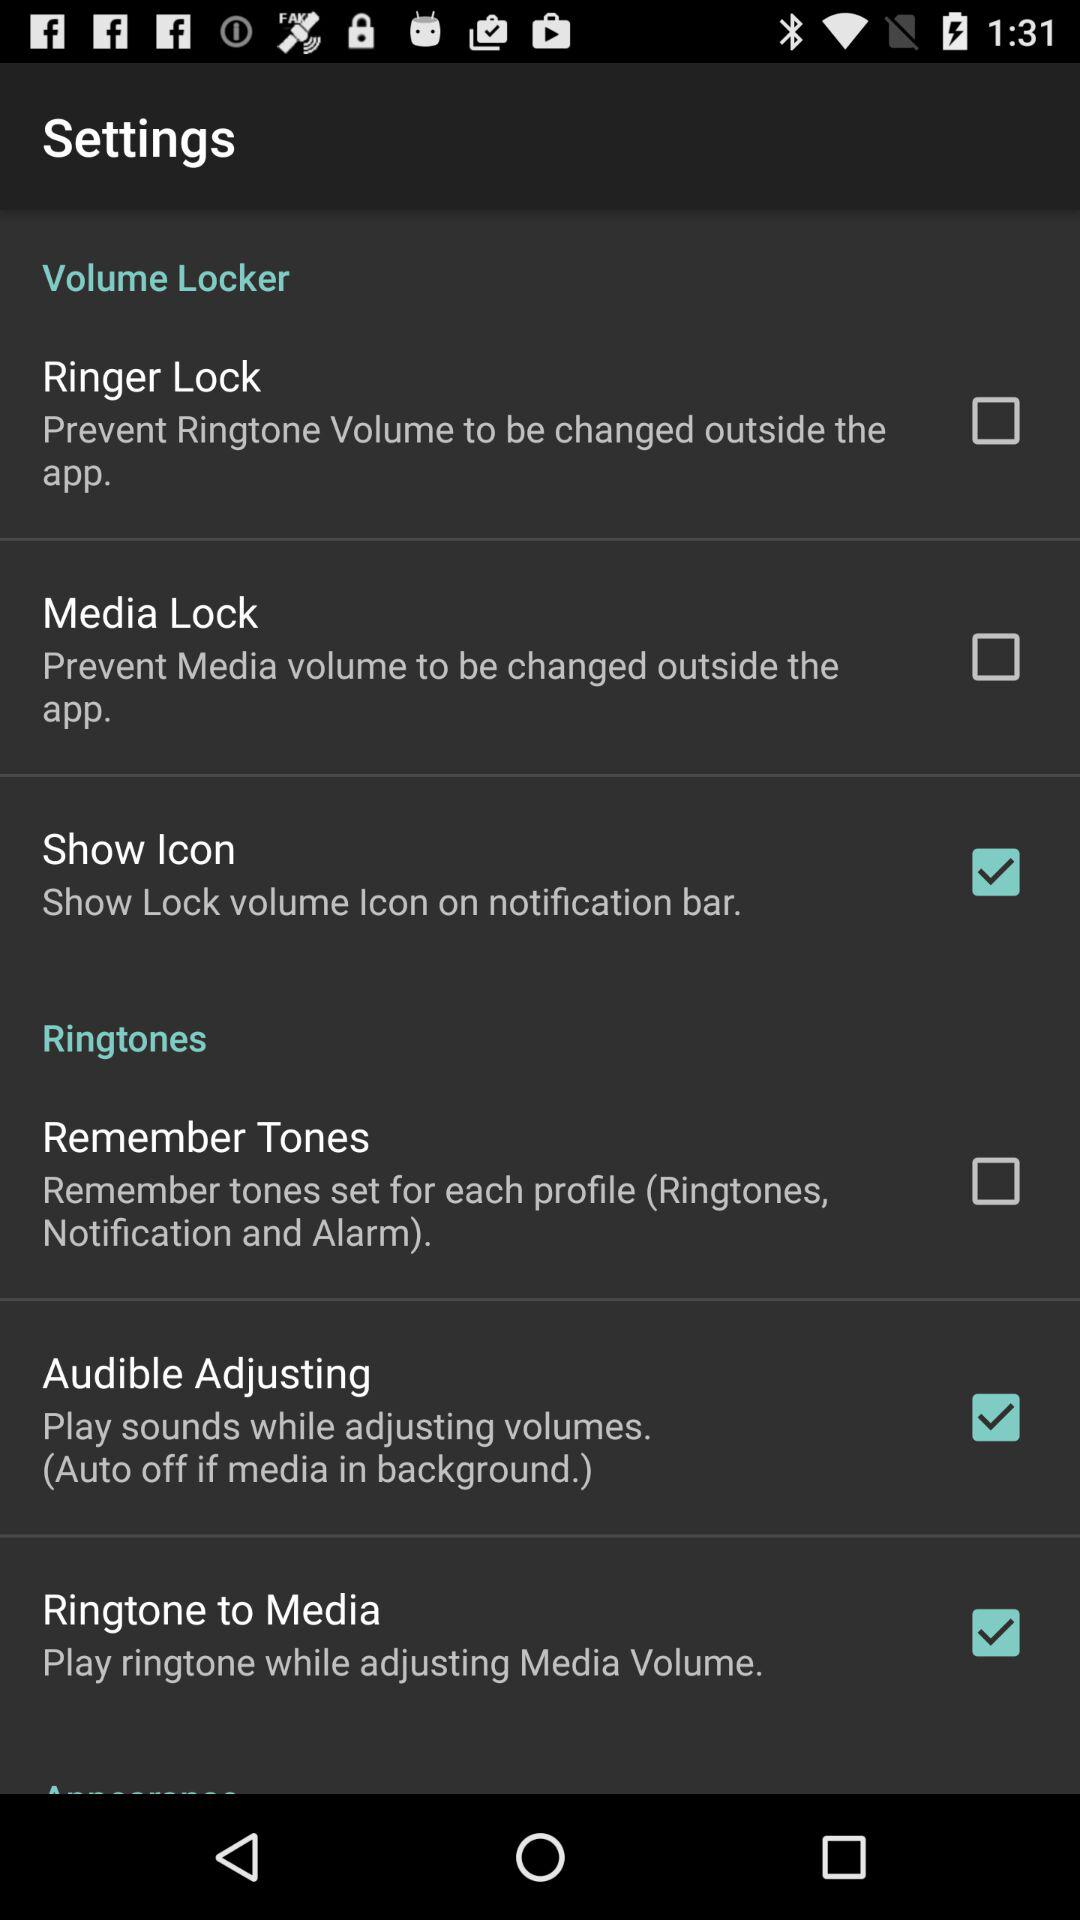What is the status of "Show Icon"? The status is "on". 